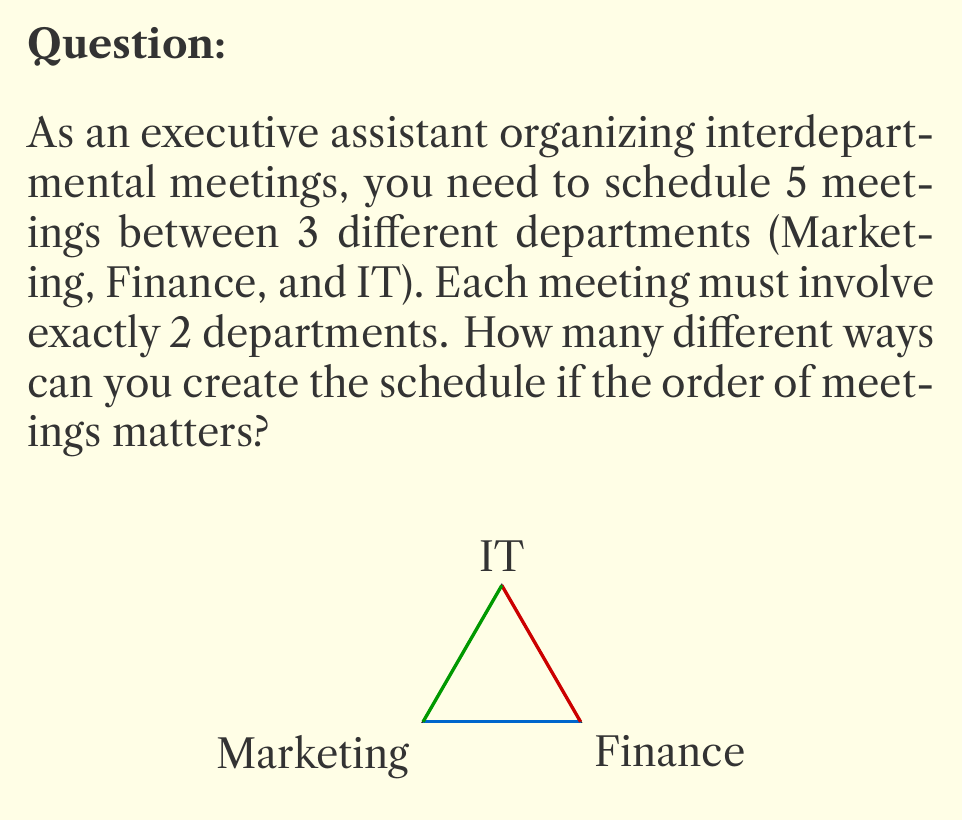Help me with this question. Let's approach this step-by-step:

1) First, we need to determine how many possible combinations of 2 departments we can have:
   - Marketing and Finance
   - Marketing and IT
   - Finance and IT
   So, there are 3 possible combinations for each meeting.

2) Now, for each of the 5 meetings, we have 3 choices. This is a case of independent events, so we multiply the number of choices for each meeting:

   $3 \times 3 \times 3 \times 3 \times 3 = 3^5$

3) However, this only accounts for the combinations of departments. We also need to consider the order of meetings, as the question states that the order matters.

4) For 5 meetings, we have 5! (5 factorial) ways to arrange them. This is because:
   - We have 5 choices for the first meeting
   - 4 choices for the second
   - 3 for the third
   - 2 for the fourth
   - 1 for the last

5) Therefore, the total number of possible schedules is:

   $3^5 \times 5! = 243 \times 120 = 29,160$

This calculation combines the number of ways to choose the department pairs (3^5) with the number of ways to order these choices (5!).
Answer: 29,160 